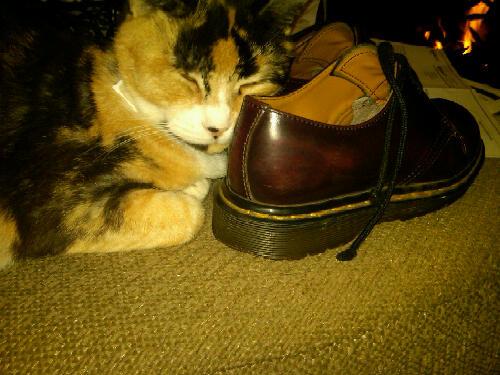Does the cat have a toy?
Write a very short answer. No. What color is the shoe?
Give a very brief answer. Brown. Is the cat comfortable?
Be succinct. Yes. 